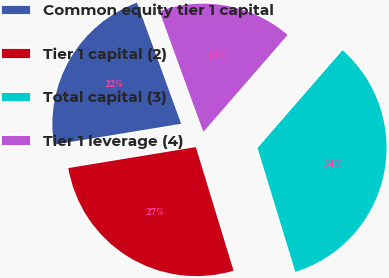<chart> <loc_0><loc_0><loc_500><loc_500><pie_chart><fcel>Common equity tier 1 capital<fcel>Tier 1 capital (2)<fcel>Total capital (3)<fcel>Tier 1 leverage (4)<nl><fcel>22.03%<fcel>27.12%<fcel>33.9%<fcel>16.95%<nl></chart> 